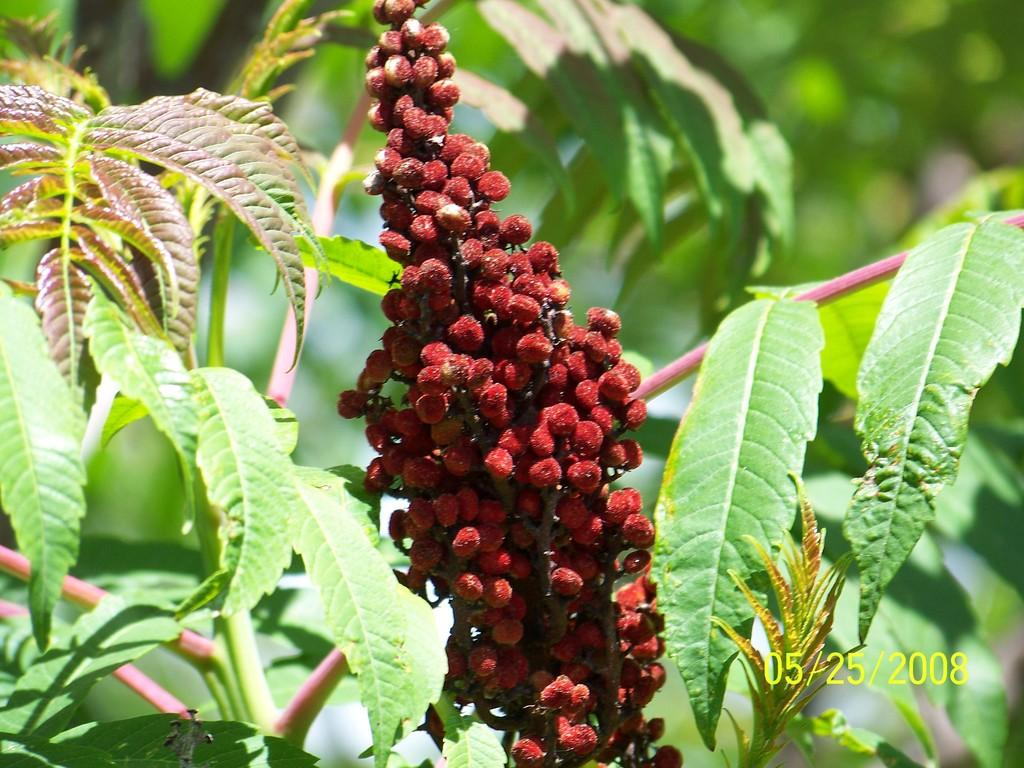What types of food items are present in the image? The image contains fruits. What else can be seen in the image besides the fruits? The image contains leaves and a plant. How would you describe the background of the image? The background of the image is blurred. What kind of natural elements can be seen in the background? There is greenery in the background of the image. What type of zephyr can be seen blowing through the scene in the image? There is no zephyr present in the image, as it is a term used to describe a gentle breeze, and there is no indication of wind in the image. 